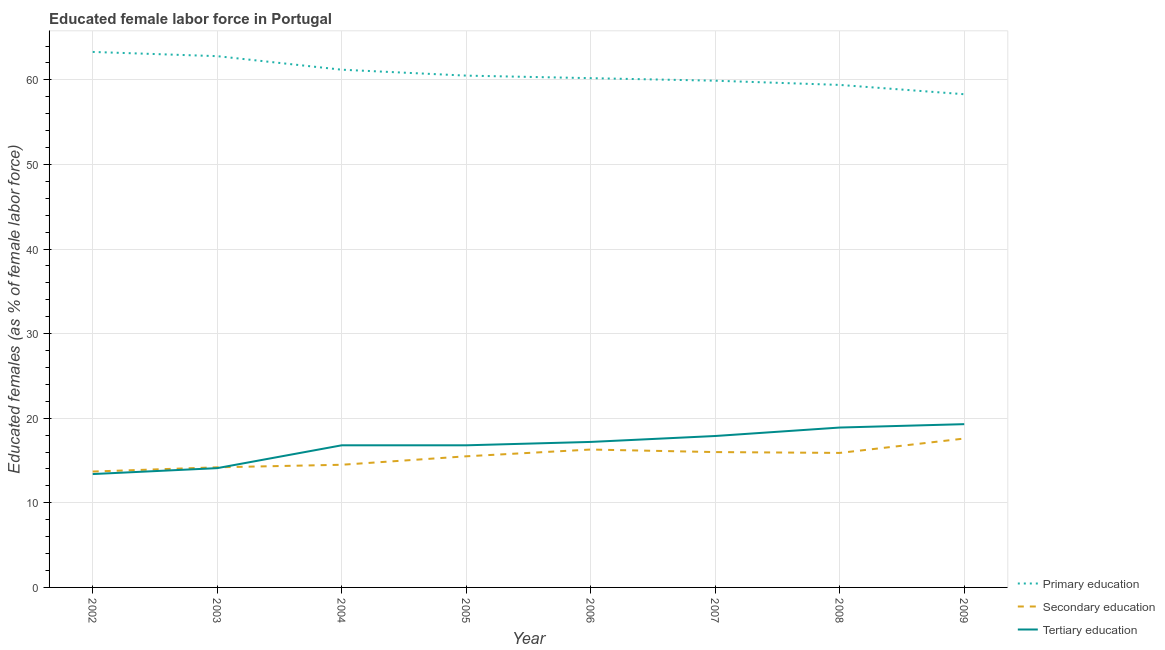How many different coloured lines are there?
Your answer should be very brief. 3. Is the number of lines equal to the number of legend labels?
Keep it short and to the point. Yes. What is the percentage of female labor force who received secondary education in 2006?
Provide a short and direct response. 16.3. Across all years, what is the maximum percentage of female labor force who received tertiary education?
Make the answer very short. 19.3. Across all years, what is the minimum percentage of female labor force who received tertiary education?
Keep it short and to the point. 13.4. In which year was the percentage of female labor force who received tertiary education maximum?
Your answer should be compact. 2009. What is the total percentage of female labor force who received secondary education in the graph?
Your response must be concise. 123.7. What is the difference between the percentage of female labor force who received secondary education in 2004 and that in 2007?
Offer a very short reply. -1.5. What is the difference between the percentage of female labor force who received tertiary education in 2002 and the percentage of female labor force who received secondary education in 2003?
Keep it short and to the point. -0.8. What is the average percentage of female labor force who received primary education per year?
Provide a short and direct response. 60.7. In the year 2004, what is the difference between the percentage of female labor force who received primary education and percentage of female labor force who received secondary education?
Offer a very short reply. 46.7. What is the ratio of the percentage of female labor force who received tertiary education in 2005 to that in 2008?
Give a very brief answer. 0.89. Is the percentage of female labor force who received primary education in 2004 less than that in 2007?
Provide a succinct answer. No. What is the difference between the highest and the second highest percentage of female labor force who received secondary education?
Your response must be concise. 1.3. In how many years, is the percentage of female labor force who received secondary education greater than the average percentage of female labor force who received secondary education taken over all years?
Your answer should be very brief. 5. Is the sum of the percentage of female labor force who received primary education in 2002 and 2009 greater than the maximum percentage of female labor force who received secondary education across all years?
Keep it short and to the point. Yes. Does the percentage of female labor force who received primary education monotonically increase over the years?
Offer a terse response. No. Is the percentage of female labor force who received secondary education strictly greater than the percentage of female labor force who received primary education over the years?
Ensure brevity in your answer.  No. How many years are there in the graph?
Give a very brief answer. 8. What is the difference between two consecutive major ticks on the Y-axis?
Your answer should be compact. 10. Are the values on the major ticks of Y-axis written in scientific E-notation?
Offer a terse response. No. Does the graph contain any zero values?
Offer a terse response. No. Does the graph contain grids?
Ensure brevity in your answer.  Yes. How many legend labels are there?
Provide a short and direct response. 3. How are the legend labels stacked?
Provide a succinct answer. Vertical. What is the title of the graph?
Give a very brief answer. Educated female labor force in Portugal. Does "Maunufacturing" appear as one of the legend labels in the graph?
Give a very brief answer. No. What is the label or title of the Y-axis?
Your response must be concise. Educated females (as % of female labor force). What is the Educated females (as % of female labor force) in Primary education in 2002?
Ensure brevity in your answer.  63.3. What is the Educated females (as % of female labor force) in Secondary education in 2002?
Keep it short and to the point. 13.7. What is the Educated females (as % of female labor force) of Tertiary education in 2002?
Offer a terse response. 13.4. What is the Educated females (as % of female labor force) in Primary education in 2003?
Offer a terse response. 62.8. What is the Educated females (as % of female labor force) in Secondary education in 2003?
Offer a very short reply. 14.2. What is the Educated females (as % of female labor force) in Tertiary education in 2003?
Offer a terse response. 14.1. What is the Educated females (as % of female labor force) of Primary education in 2004?
Make the answer very short. 61.2. What is the Educated females (as % of female labor force) in Tertiary education in 2004?
Give a very brief answer. 16.8. What is the Educated females (as % of female labor force) in Primary education in 2005?
Make the answer very short. 60.5. What is the Educated females (as % of female labor force) in Tertiary education in 2005?
Give a very brief answer. 16.8. What is the Educated females (as % of female labor force) of Primary education in 2006?
Ensure brevity in your answer.  60.2. What is the Educated females (as % of female labor force) of Secondary education in 2006?
Ensure brevity in your answer.  16.3. What is the Educated females (as % of female labor force) of Tertiary education in 2006?
Make the answer very short. 17.2. What is the Educated females (as % of female labor force) of Primary education in 2007?
Give a very brief answer. 59.9. What is the Educated females (as % of female labor force) in Secondary education in 2007?
Your response must be concise. 16. What is the Educated females (as % of female labor force) in Tertiary education in 2007?
Your answer should be compact. 17.9. What is the Educated females (as % of female labor force) of Primary education in 2008?
Offer a terse response. 59.4. What is the Educated females (as % of female labor force) in Secondary education in 2008?
Your answer should be very brief. 15.9. What is the Educated females (as % of female labor force) of Tertiary education in 2008?
Offer a terse response. 18.9. What is the Educated females (as % of female labor force) of Primary education in 2009?
Provide a succinct answer. 58.3. What is the Educated females (as % of female labor force) in Secondary education in 2009?
Your answer should be compact. 17.6. What is the Educated females (as % of female labor force) in Tertiary education in 2009?
Your response must be concise. 19.3. Across all years, what is the maximum Educated females (as % of female labor force) in Primary education?
Ensure brevity in your answer.  63.3. Across all years, what is the maximum Educated females (as % of female labor force) of Secondary education?
Your answer should be very brief. 17.6. Across all years, what is the maximum Educated females (as % of female labor force) in Tertiary education?
Your answer should be very brief. 19.3. Across all years, what is the minimum Educated females (as % of female labor force) in Primary education?
Offer a very short reply. 58.3. Across all years, what is the minimum Educated females (as % of female labor force) in Secondary education?
Offer a very short reply. 13.7. Across all years, what is the minimum Educated females (as % of female labor force) in Tertiary education?
Keep it short and to the point. 13.4. What is the total Educated females (as % of female labor force) in Primary education in the graph?
Your answer should be very brief. 485.6. What is the total Educated females (as % of female labor force) of Secondary education in the graph?
Your response must be concise. 123.7. What is the total Educated females (as % of female labor force) of Tertiary education in the graph?
Give a very brief answer. 134.4. What is the difference between the Educated females (as % of female labor force) in Secondary education in 2002 and that in 2003?
Your answer should be very brief. -0.5. What is the difference between the Educated females (as % of female labor force) in Secondary education in 2002 and that in 2004?
Your response must be concise. -0.8. What is the difference between the Educated females (as % of female labor force) in Primary education in 2002 and that in 2005?
Provide a succinct answer. 2.8. What is the difference between the Educated females (as % of female labor force) in Secondary education in 2002 and that in 2005?
Keep it short and to the point. -1.8. What is the difference between the Educated females (as % of female labor force) in Tertiary education in 2002 and that in 2006?
Your answer should be compact. -3.8. What is the difference between the Educated females (as % of female labor force) of Secondary education in 2002 and that in 2007?
Your answer should be very brief. -2.3. What is the difference between the Educated females (as % of female labor force) in Tertiary education in 2002 and that in 2008?
Your answer should be very brief. -5.5. What is the difference between the Educated females (as % of female labor force) of Secondary education in 2002 and that in 2009?
Ensure brevity in your answer.  -3.9. What is the difference between the Educated females (as % of female labor force) of Secondary education in 2003 and that in 2004?
Provide a short and direct response. -0.3. What is the difference between the Educated females (as % of female labor force) in Tertiary education in 2003 and that in 2004?
Ensure brevity in your answer.  -2.7. What is the difference between the Educated females (as % of female labor force) in Secondary education in 2003 and that in 2005?
Offer a terse response. -1.3. What is the difference between the Educated females (as % of female labor force) of Primary education in 2003 and that in 2006?
Ensure brevity in your answer.  2.6. What is the difference between the Educated females (as % of female labor force) in Secondary education in 2003 and that in 2006?
Keep it short and to the point. -2.1. What is the difference between the Educated females (as % of female labor force) in Primary education in 2003 and that in 2007?
Ensure brevity in your answer.  2.9. What is the difference between the Educated females (as % of female labor force) in Secondary education in 2003 and that in 2007?
Make the answer very short. -1.8. What is the difference between the Educated females (as % of female labor force) of Primary education in 2003 and that in 2008?
Keep it short and to the point. 3.4. What is the difference between the Educated females (as % of female labor force) in Secondary education in 2003 and that in 2008?
Your response must be concise. -1.7. What is the difference between the Educated females (as % of female labor force) in Tertiary education in 2003 and that in 2009?
Give a very brief answer. -5.2. What is the difference between the Educated females (as % of female labor force) in Primary education in 2004 and that in 2005?
Offer a terse response. 0.7. What is the difference between the Educated females (as % of female labor force) in Secondary education in 2004 and that in 2005?
Ensure brevity in your answer.  -1. What is the difference between the Educated females (as % of female labor force) in Tertiary education in 2004 and that in 2005?
Provide a short and direct response. 0. What is the difference between the Educated females (as % of female labor force) in Primary education in 2004 and that in 2006?
Your response must be concise. 1. What is the difference between the Educated females (as % of female labor force) in Primary education in 2004 and that in 2007?
Give a very brief answer. 1.3. What is the difference between the Educated females (as % of female labor force) of Secondary education in 2004 and that in 2007?
Ensure brevity in your answer.  -1.5. What is the difference between the Educated females (as % of female labor force) of Tertiary education in 2004 and that in 2007?
Make the answer very short. -1.1. What is the difference between the Educated females (as % of female labor force) of Primary education in 2004 and that in 2009?
Give a very brief answer. 2.9. What is the difference between the Educated females (as % of female labor force) in Tertiary education in 2004 and that in 2009?
Your response must be concise. -2.5. What is the difference between the Educated females (as % of female labor force) of Primary education in 2005 and that in 2006?
Your answer should be compact. 0.3. What is the difference between the Educated females (as % of female labor force) in Tertiary education in 2005 and that in 2006?
Provide a succinct answer. -0.4. What is the difference between the Educated females (as % of female labor force) in Primary education in 2005 and that in 2007?
Offer a very short reply. 0.6. What is the difference between the Educated females (as % of female labor force) in Secondary education in 2005 and that in 2007?
Offer a terse response. -0.5. What is the difference between the Educated females (as % of female labor force) of Primary education in 2005 and that in 2008?
Make the answer very short. 1.1. What is the difference between the Educated females (as % of female labor force) of Primary education in 2005 and that in 2009?
Keep it short and to the point. 2.2. What is the difference between the Educated females (as % of female labor force) in Secondary education in 2005 and that in 2009?
Your response must be concise. -2.1. What is the difference between the Educated females (as % of female labor force) in Primary education in 2006 and that in 2007?
Ensure brevity in your answer.  0.3. What is the difference between the Educated females (as % of female labor force) of Secondary education in 2006 and that in 2007?
Your response must be concise. 0.3. What is the difference between the Educated females (as % of female labor force) of Tertiary education in 2006 and that in 2007?
Ensure brevity in your answer.  -0.7. What is the difference between the Educated females (as % of female labor force) of Secondary education in 2006 and that in 2008?
Keep it short and to the point. 0.4. What is the difference between the Educated females (as % of female labor force) in Tertiary education in 2006 and that in 2008?
Make the answer very short. -1.7. What is the difference between the Educated females (as % of female labor force) in Secondary education in 2006 and that in 2009?
Your answer should be very brief. -1.3. What is the difference between the Educated females (as % of female labor force) of Tertiary education in 2006 and that in 2009?
Your answer should be very brief. -2.1. What is the difference between the Educated females (as % of female labor force) of Primary education in 2007 and that in 2009?
Your response must be concise. 1.6. What is the difference between the Educated females (as % of female labor force) of Secondary education in 2007 and that in 2009?
Keep it short and to the point. -1.6. What is the difference between the Educated females (as % of female labor force) of Primary education in 2008 and that in 2009?
Your response must be concise. 1.1. What is the difference between the Educated females (as % of female labor force) in Primary education in 2002 and the Educated females (as % of female labor force) in Secondary education in 2003?
Provide a short and direct response. 49.1. What is the difference between the Educated females (as % of female labor force) of Primary education in 2002 and the Educated females (as % of female labor force) of Tertiary education in 2003?
Ensure brevity in your answer.  49.2. What is the difference between the Educated females (as % of female labor force) of Secondary education in 2002 and the Educated females (as % of female labor force) of Tertiary education in 2003?
Provide a short and direct response. -0.4. What is the difference between the Educated females (as % of female labor force) in Primary education in 2002 and the Educated females (as % of female labor force) in Secondary education in 2004?
Your response must be concise. 48.8. What is the difference between the Educated females (as % of female labor force) of Primary education in 2002 and the Educated females (as % of female labor force) of Tertiary education in 2004?
Give a very brief answer. 46.5. What is the difference between the Educated females (as % of female labor force) in Secondary education in 2002 and the Educated females (as % of female labor force) in Tertiary education in 2004?
Give a very brief answer. -3.1. What is the difference between the Educated females (as % of female labor force) in Primary education in 2002 and the Educated females (as % of female labor force) in Secondary education in 2005?
Keep it short and to the point. 47.8. What is the difference between the Educated females (as % of female labor force) in Primary education in 2002 and the Educated females (as % of female labor force) in Tertiary education in 2005?
Your answer should be compact. 46.5. What is the difference between the Educated females (as % of female labor force) in Primary education in 2002 and the Educated females (as % of female labor force) in Tertiary education in 2006?
Offer a very short reply. 46.1. What is the difference between the Educated females (as % of female labor force) in Secondary education in 2002 and the Educated females (as % of female labor force) in Tertiary education in 2006?
Your answer should be compact. -3.5. What is the difference between the Educated females (as % of female labor force) of Primary education in 2002 and the Educated females (as % of female labor force) of Secondary education in 2007?
Make the answer very short. 47.3. What is the difference between the Educated females (as % of female labor force) of Primary education in 2002 and the Educated females (as % of female labor force) of Tertiary education in 2007?
Your response must be concise. 45.4. What is the difference between the Educated females (as % of female labor force) in Primary education in 2002 and the Educated females (as % of female labor force) in Secondary education in 2008?
Keep it short and to the point. 47.4. What is the difference between the Educated females (as % of female labor force) in Primary education in 2002 and the Educated females (as % of female labor force) in Tertiary education in 2008?
Your answer should be very brief. 44.4. What is the difference between the Educated females (as % of female labor force) of Secondary education in 2002 and the Educated females (as % of female labor force) of Tertiary education in 2008?
Provide a succinct answer. -5.2. What is the difference between the Educated females (as % of female labor force) of Primary education in 2002 and the Educated females (as % of female labor force) of Secondary education in 2009?
Provide a short and direct response. 45.7. What is the difference between the Educated females (as % of female labor force) of Primary education in 2002 and the Educated females (as % of female labor force) of Tertiary education in 2009?
Your answer should be very brief. 44. What is the difference between the Educated females (as % of female labor force) of Primary education in 2003 and the Educated females (as % of female labor force) of Secondary education in 2004?
Make the answer very short. 48.3. What is the difference between the Educated females (as % of female labor force) in Primary education in 2003 and the Educated females (as % of female labor force) in Tertiary education in 2004?
Your response must be concise. 46. What is the difference between the Educated females (as % of female labor force) of Secondary education in 2003 and the Educated females (as % of female labor force) of Tertiary education in 2004?
Make the answer very short. -2.6. What is the difference between the Educated females (as % of female labor force) of Primary education in 2003 and the Educated females (as % of female labor force) of Secondary education in 2005?
Offer a very short reply. 47.3. What is the difference between the Educated females (as % of female labor force) of Primary education in 2003 and the Educated females (as % of female labor force) of Tertiary education in 2005?
Give a very brief answer. 46. What is the difference between the Educated females (as % of female labor force) in Primary education in 2003 and the Educated females (as % of female labor force) in Secondary education in 2006?
Your answer should be very brief. 46.5. What is the difference between the Educated females (as % of female labor force) of Primary education in 2003 and the Educated females (as % of female labor force) of Tertiary education in 2006?
Your response must be concise. 45.6. What is the difference between the Educated females (as % of female labor force) of Primary education in 2003 and the Educated females (as % of female labor force) of Secondary education in 2007?
Give a very brief answer. 46.8. What is the difference between the Educated females (as % of female labor force) in Primary education in 2003 and the Educated females (as % of female labor force) in Tertiary education in 2007?
Your answer should be compact. 44.9. What is the difference between the Educated females (as % of female labor force) of Secondary education in 2003 and the Educated females (as % of female labor force) of Tertiary education in 2007?
Ensure brevity in your answer.  -3.7. What is the difference between the Educated females (as % of female labor force) in Primary education in 2003 and the Educated females (as % of female labor force) in Secondary education in 2008?
Give a very brief answer. 46.9. What is the difference between the Educated females (as % of female labor force) in Primary education in 2003 and the Educated females (as % of female labor force) in Tertiary education in 2008?
Provide a succinct answer. 43.9. What is the difference between the Educated females (as % of female labor force) of Primary education in 2003 and the Educated females (as % of female labor force) of Secondary education in 2009?
Your answer should be very brief. 45.2. What is the difference between the Educated females (as % of female labor force) in Primary education in 2003 and the Educated females (as % of female labor force) in Tertiary education in 2009?
Ensure brevity in your answer.  43.5. What is the difference between the Educated females (as % of female labor force) of Secondary education in 2003 and the Educated females (as % of female labor force) of Tertiary education in 2009?
Give a very brief answer. -5.1. What is the difference between the Educated females (as % of female labor force) in Primary education in 2004 and the Educated females (as % of female labor force) in Secondary education in 2005?
Offer a very short reply. 45.7. What is the difference between the Educated females (as % of female labor force) in Primary education in 2004 and the Educated females (as % of female labor force) in Tertiary education in 2005?
Ensure brevity in your answer.  44.4. What is the difference between the Educated females (as % of female labor force) of Secondary education in 2004 and the Educated females (as % of female labor force) of Tertiary education in 2005?
Your answer should be compact. -2.3. What is the difference between the Educated females (as % of female labor force) in Primary education in 2004 and the Educated females (as % of female labor force) in Secondary education in 2006?
Your response must be concise. 44.9. What is the difference between the Educated females (as % of female labor force) of Primary education in 2004 and the Educated females (as % of female labor force) of Secondary education in 2007?
Provide a short and direct response. 45.2. What is the difference between the Educated females (as % of female labor force) of Primary education in 2004 and the Educated females (as % of female labor force) of Tertiary education in 2007?
Offer a terse response. 43.3. What is the difference between the Educated females (as % of female labor force) in Primary education in 2004 and the Educated females (as % of female labor force) in Secondary education in 2008?
Your answer should be compact. 45.3. What is the difference between the Educated females (as % of female labor force) of Primary education in 2004 and the Educated females (as % of female labor force) of Tertiary education in 2008?
Your answer should be compact. 42.3. What is the difference between the Educated females (as % of female labor force) of Secondary education in 2004 and the Educated females (as % of female labor force) of Tertiary education in 2008?
Give a very brief answer. -4.4. What is the difference between the Educated females (as % of female labor force) in Primary education in 2004 and the Educated females (as % of female labor force) in Secondary education in 2009?
Give a very brief answer. 43.6. What is the difference between the Educated females (as % of female labor force) in Primary education in 2004 and the Educated females (as % of female labor force) in Tertiary education in 2009?
Make the answer very short. 41.9. What is the difference between the Educated females (as % of female labor force) of Primary education in 2005 and the Educated females (as % of female labor force) of Secondary education in 2006?
Make the answer very short. 44.2. What is the difference between the Educated females (as % of female labor force) of Primary education in 2005 and the Educated females (as % of female labor force) of Tertiary education in 2006?
Your response must be concise. 43.3. What is the difference between the Educated females (as % of female labor force) in Secondary education in 2005 and the Educated females (as % of female labor force) in Tertiary education in 2006?
Make the answer very short. -1.7. What is the difference between the Educated females (as % of female labor force) of Primary education in 2005 and the Educated females (as % of female labor force) of Secondary education in 2007?
Your response must be concise. 44.5. What is the difference between the Educated females (as % of female labor force) in Primary education in 2005 and the Educated females (as % of female labor force) in Tertiary education in 2007?
Make the answer very short. 42.6. What is the difference between the Educated females (as % of female labor force) in Primary education in 2005 and the Educated females (as % of female labor force) in Secondary education in 2008?
Keep it short and to the point. 44.6. What is the difference between the Educated females (as % of female labor force) of Primary education in 2005 and the Educated females (as % of female labor force) of Tertiary education in 2008?
Provide a short and direct response. 41.6. What is the difference between the Educated females (as % of female labor force) in Secondary education in 2005 and the Educated females (as % of female labor force) in Tertiary education in 2008?
Your answer should be compact. -3.4. What is the difference between the Educated females (as % of female labor force) of Primary education in 2005 and the Educated females (as % of female labor force) of Secondary education in 2009?
Keep it short and to the point. 42.9. What is the difference between the Educated females (as % of female labor force) in Primary education in 2005 and the Educated females (as % of female labor force) in Tertiary education in 2009?
Offer a very short reply. 41.2. What is the difference between the Educated females (as % of female labor force) in Secondary education in 2005 and the Educated females (as % of female labor force) in Tertiary education in 2009?
Your answer should be compact. -3.8. What is the difference between the Educated females (as % of female labor force) in Primary education in 2006 and the Educated females (as % of female labor force) in Secondary education in 2007?
Ensure brevity in your answer.  44.2. What is the difference between the Educated females (as % of female labor force) of Primary education in 2006 and the Educated females (as % of female labor force) of Tertiary education in 2007?
Your answer should be very brief. 42.3. What is the difference between the Educated females (as % of female labor force) in Primary education in 2006 and the Educated females (as % of female labor force) in Secondary education in 2008?
Your response must be concise. 44.3. What is the difference between the Educated females (as % of female labor force) of Primary education in 2006 and the Educated females (as % of female labor force) of Tertiary education in 2008?
Ensure brevity in your answer.  41.3. What is the difference between the Educated females (as % of female labor force) of Secondary education in 2006 and the Educated females (as % of female labor force) of Tertiary education in 2008?
Ensure brevity in your answer.  -2.6. What is the difference between the Educated females (as % of female labor force) in Primary education in 2006 and the Educated females (as % of female labor force) in Secondary education in 2009?
Provide a short and direct response. 42.6. What is the difference between the Educated females (as % of female labor force) of Primary education in 2006 and the Educated females (as % of female labor force) of Tertiary education in 2009?
Provide a succinct answer. 40.9. What is the difference between the Educated females (as % of female labor force) in Secondary education in 2006 and the Educated females (as % of female labor force) in Tertiary education in 2009?
Offer a terse response. -3. What is the difference between the Educated females (as % of female labor force) of Primary education in 2007 and the Educated females (as % of female labor force) of Secondary education in 2008?
Give a very brief answer. 44. What is the difference between the Educated females (as % of female labor force) in Primary education in 2007 and the Educated females (as % of female labor force) in Secondary education in 2009?
Your answer should be compact. 42.3. What is the difference between the Educated females (as % of female labor force) of Primary education in 2007 and the Educated females (as % of female labor force) of Tertiary education in 2009?
Ensure brevity in your answer.  40.6. What is the difference between the Educated females (as % of female labor force) of Primary education in 2008 and the Educated females (as % of female labor force) of Secondary education in 2009?
Ensure brevity in your answer.  41.8. What is the difference between the Educated females (as % of female labor force) of Primary education in 2008 and the Educated females (as % of female labor force) of Tertiary education in 2009?
Make the answer very short. 40.1. What is the difference between the Educated females (as % of female labor force) of Secondary education in 2008 and the Educated females (as % of female labor force) of Tertiary education in 2009?
Give a very brief answer. -3.4. What is the average Educated females (as % of female labor force) of Primary education per year?
Provide a short and direct response. 60.7. What is the average Educated females (as % of female labor force) in Secondary education per year?
Your answer should be compact. 15.46. In the year 2002, what is the difference between the Educated females (as % of female labor force) in Primary education and Educated females (as % of female labor force) in Secondary education?
Give a very brief answer. 49.6. In the year 2002, what is the difference between the Educated females (as % of female labor force) in Primary education and Educated females (as % of female labor force) in Tertiary education?
Keep it short and to the point. 49.9. In the year 2002, what is the difference between the Educated females (as % of female labor force) in Secondary education and Educated females (as % of female labor force) in Tertiary education?
Ensure brevity in your answer.  0.3. In the year 2003, what is the difference between the Educated females (as % of female labor force) of Primary education and Educated females (as % of female labor force) of Secondary education?
Offer a terse response. 48.6. In the year 2003, what is the difference between the Educated females (as % of female labor force) of Primary education and Educated females (as % of female labor force) of Tertiary education?
Your answer should be compact. 48.7. In the year 2004, what is the difference between the Educated females (as % of female labor force) in Primary education and Educated females (as % of female labor force) in Secondary education?
Ensure brevity in your answer.  46.7. In the year 2004, what is the difference between the Educated females (as % of female labor force) of Primary education and Educated females (as % of female labor force) of Tertiary education?
Provide a succinct answer. 44.4. In the year 2005, what is the difference between the Educated females (as % of female labor force) in Primary education and Educated females (as % of female labor force) in Secondary education?
Provide a succinct answer. 45. In the year 2005, what is the difference between the Educated females (as % of female labor force) of Primary education and Educated females (as % of female labor force) of Tertiary education?
Offer a very short reply. 43.7. In the year 2006, what is the difference between the Educated females (as % of female labor force) of Primary education and Educated females (as % of female labor force) of Secondary education?
Your answer should be compact. 43.9. In the year 2007, what is the difference between the Educated females (as % of female labor force) in Primary education and Educated females (as % of female labor force) in Secondary education?
Your answer should be compact. 43.9. In the year 2007, what is the difference between the Educated females (as % of female labor force) in Primary education and Educated females (as % of female labor force) in Tertiary education?
Make the answer very short. 42. In the year 2007, what is the difference between the Educated females (as % of female labor force) of Secondary education and Educated females (as % of female labor force) of Tertiary education?
Provide a short and direct response. -1.9. In the year 2008, what is the difference between the Educated females (as % of female labor force) in Primary education and Educated females (as % of female labor force) in Secondary education?
Offer a very short reply. 43.5. In the year 2008, what is the difference between the Educated females (as % of female labor force) in Primary education and Educated females (as % of female labor force) in Tertiary education?
Provide a short and direct response. 40.5. In the year 2009, what is the difference between the Educated females (as % of female labor force) in Primary education and Educated females (as % of female labor force) in Secondary education?
Your response must be concise. 40.7. In the year 2009, what is the difference between the Educated females (as % of female labor force) in Primary education and Educated females (as % of female labor force) in Tertiary education?
Give a very brief answer. 39. In the year 2009, what is the difference between the Educated females (as % of female labor force) in Secondary education and Educated females (as % of female labor force) in Tertiary education?
Provide a succinct answer. -1.7. What is the ratio of the Educated females (as % of female labor force) in Primary education in 2002 to that in 2003?
Your response must be concise. 1.01. What is the ratio of the Educated females (as % of female labor force) in Secondary education in 2002 to that in 2003?
Give a very brief answer. 0.96. What is the ratio of the Educated females (as % of female labor force) of Tertiary education in 2002 to that in 2003?
Your response must be concise. 0.95. What is the ratio of the Educated females (as % of female labor force) of Primary education in 2002 to that in 2004?
Provide a short and direct response. 1.03. What is the ratio of the Educated females (as % of female labor force) of Secondary education in 2002 to that in 2004?
Provide a succinct answer. 0.94. What is the ratio of the Educated females (as % of female labor force) in Tertiary education in 2002 to that in 2004?
Provide a short and direct response. 0.8. What is the ratio of the Educated females (as % of female labor force) in Primary education in 2002 to that in 2005?
Provide a succinct answer. 1.05. What is the ratio of the Educated females (as % of female labor force) in Secondary education in 2002 to that in 2005?
Offer a very short reply. 0.88. What is the ratio of the Educated females (as % of female labor force) of Tertiary education in 2002 to that in 2005?
Make the answer very short. 0.8. What is the ratio of the Educated females (as % of female labor force) of Primary education in 2002 to that in 2006?
Provide a succinct answer. 1.05. What is the ratio of the Educated females (as % of female labor force) of Secondary education in 2002 to that in 2006?
Ensure brevity in your answer.  0.84. What is the ratio of the Educated females (as % of female labor force) in Tertiary education in 2002 to that in 2006?
Your answer should be very brief. 0.78. What is the ratio of the Educated females (as % of female labor force) of Primary education in 2002 to that in 2007?
Ensure brevity in your answer.  1.06. What is the ratio of the Educated females (as % of female labor force) of Secondary education in 2002 to that in 2007?
Your answer should be compact. 0.86. What is the ratio of the Educated females (as % of female labor force) of Tertiary education in 2002 to that in 2007?
Provide a short and direct response. 0.75. What is the ratio of the Educated females (as % of female labor force) in Primary education in 2002 to that in 2008?
Offer a very short reply. 1.07. What is the ratio of the Educated females (as % of female labor force) of Secondary education in 2002 to that in 2008?
Offer a very short reply. 0.86. What is the ratio of the Educated females (as % of female labor force) in Tertiary education in 2002 to that in 2008?
Make the answer very short. 0.71. What is the ratio of the Educated females (as % of female labor force) in Primary education in 2002 to that in 2009?
Make the answer very short. 1.09. What is the ratio of the Educated females (as % of female labor force) of Secondary education in 2002 to that in 2009?
Offer a terse response. 0.78. What is the ratio of the Educated females (as % of female labor force) in Tertiary education in 2002 to that in 2009?
Give a very brief answer. 0.69. What is the ratio of the Educated females (as % of female labor force) of Primary education in 2003 to that in 2004?
Offer a very short reply. 1.03. What is the ratio of the Educated females (as % of female labor force) in Secondary education in 2003 to that in 2004?
Give a very brief answer. 0.98. What is the ratio of the Educated females (as % of female labor force) of Tertiary education in 2003 to that in 2004?
Give a very brief answer. 0.84. What is the ratio of the Educated females (as % of female labor force) of Primary education in 2003 to that in 2005?
Offer a very short reply. 1.04. What is the ratio of the Educated females (as % of female labor force) in Secondary education in 2003 to that in 2005?
Offer a very short reply. 0.92. What is the ratio of the Educated females (as % of female labor force) of Tertiary education in 2003 to that in 2005?
Your answer should be very brief. 0.84. What is the ratio of the Educated females (as % of female labor force) of Primary education in 2003 to that in 2006?
Your response must be concise. 1.04. What is the ratio of the Educated females (as % of female labor force) in Secondary education in 2003 to that in 2006?
Give a very brief answer. 0.87. What is the ratio of the Educated females (as % of female labor force) of Tertiary education in 2003 to that in 2006?
Provide a short and direct response. 0.82. What is the ratio of the Educated females (as % of female labor force) in Primary education in 2003 to that in 2007?
Provide a short and direct response. 1.05. What is the ratio of the Educated females (as % of female labor force) in Secondary education in 2003 to that in 2007?
Give a very brief answer. 0.89. What is the ratio of the Educated females (as % of female labor force) in Tertiary education in 2003 to that in 2007?
Give a very brief answer. 0.79. What is the ratio of the Educated females (as % of female labor force) in Primary education in 2003 to that in 2008?
Your response must be concise. 1.06. What is the ratio of the Educated females (as % of female labor force) in Secondary education in 2003 to that in 2008?
Provide a short and direct response. 0.89. What is the ratio of the Educated females (as % of female labor force) in Tertiary education in 2003 to that in 2008?
Your answer should be compact. 0.75. What is the ratio of the Educated females (as % of female labor force) in Primary education in 2003 to that in 2009?
Offer a terse response. 1.08. What is the ratio of the Educated females (as % of female labor force) in Secondary education in 2003 to that in 2009?
Offer a very short reply. 0.81. What is the ratio of the Educated females (as % of female labor force) of Tertiary education in 2003 to that in 2009?
Keep it short and to the point. 0.73. What is the ratio of the Educated females (as % of female labor force) in Primary education in 2004 to that in 2005?
Provide a succinct answer. 1.01. What is the ratio of the Educated females (as % of female labor force) of Secondary education in 2004 to that in 2005?
Keep it short and to the point. 0.94. What is the ratio of the Educated females (as % of female labor force) of Tertiary education in 2004 to that in 2005?
Give a very brief answer. 1. What is the ratio of the Educated females (as % of female labor force) of Primary education in 2004 to that in 2006?
Your response must be concise. 1.02. What is the ratio of the Educated females (as % of female labor force) in Secondary education in 2004 to that in 2006?
Offer a very short reply. 0.89. What is the ratio of the Educated females (as % of female labor force) of Tertiary education in 2004 to that in 2006?
Offer a very short reply. 0.98. What is the ratio of the Educated females (as % of female labor force) of Primary education in 2004 to that in 2007?
Keep it short and to the point. 1.02. What is the ratio of the Educated females (as % of female labor force) in Secondary education in 2004 to that in 2007?
Make the answer very short. 0.91. What is the ratio of the Educated females (as % of female labor force) in Tertiary education in 2004 to that in 2007?
Your answer should be very brief. 0.94. What is the ratio of the Educated females (as % of female labor force) in Primary education in 2004 to that in 2008?
Give a very brief answer. 1.03. What is the ratio of the Educated females (as % of female labor force) in Secondary education in 2004 to that in 2008?
Offer a terse response. 0.91. What is the ratio of the Educated females (as % of female labor force) in Primary education in 2004 to that in 2009?
Your answer should be compact. 1.05. What is the ratio of the Educated females (as % of female labor force) of Secondary education in 2004 to that in 2009?
Your answer should be compact. 0.82. What is the ratio of the Educated females (as % of female labor force) in Tertiary education in 2004 to that in 2009?
Offer a very short reply. 0.87. What is the ratio of the Educated females (as % of female labor force) in Secondary education in 2005 to that in 2006?
Give a very brief answer. 0.95. What is the ratio of the Educated females (as % of female labor force) in Tertiary education in 2005 to that in 2006?
Make the answer very short. 0.98. What is the ratio of the Educated females (as % of female labor force) in Primary education in 2005 to that in 2007?
Your answer should be compact. 1.01. What is the ratio of the Educated females (as % of female labor force) of Secondary education in 2005 to that in 2007?
Provide a succinct answer. 0.97. What is the ratio of the Educated females (as % of female labor force) of Tertiary education in 2005 to that in 2007?
Offer a very short reply. 0.94. What is the ratio of the Educated females (as % of female labor force) of Primary education in 2005 to that in 2008?
Keep it short and to the point. 1.02. What is the ratio of the Educated females (as % of female labor force) in Secondary education in 2005 to that in 2008?
Provide a short and direct response. 0.97. What is the ratio of the Educated females (as % of female labor force) of Primary education in 2005 to that in 2009?
Your response must be concise. 1.04. What is the ratio of the Educated females (as % of female labor force) of Secondary education in 2005 to that in 2009?
Offer a very short reply. 0.88. What is the ratio of the Educated females (as % of female labor force) in Tertiary education in 2005 to that in 2009?
Ensure brevity in your answer.  0.87. What is the ratio of the Educated females (as % of female labor force) of Secondary education in 2006 to that in 2007?
Ensure brevity in your answer.  1.02. What is the ratio of the Educated females (as % of female labor force) of Tertiary education in 2006 to that in 2007?
Give a very brief answer. 0.96. What is the ratio of the Educated females (as % of female labor force) in Primary education in 2006 to that in 2008?
Ensure brevity in your answer.  1.01. What is the ratio of the Educated females (as % of female labor force) of Secondary education in 2006 to that in 2008?
Offer a terse response. 1.03. What is the ratio of the Educated females (as % of female labor force) of Tertiary education in 2006 to that in 2008?
Make the answer very short. 0.91. What is the ratio of the Educated females (as % of female labor force) of Primary education in 2006 to that in 2009?
Your answer should be compact. 1.03. What is the ratio of the Educated females (as % of female labor force) of Secondary education in 2006 to that in 2009?
Offer a terse response. 0.93. What is the ratio of the Educated females (as % of female labor force) in Tertiary education in 2006 to that in 2009?
Your answer should be compact. 0.89. What is the ratio of the Educated females (as % of female labor force) of Primary education in 2007 to that in 2008?
Give a very brief answer. 1.01. What is the ratio of the Educated females (as % of female labor force) in Tertiary education in 2007 to that in 2008?
Keep it short and to the point. 0.95. What is the ratio of the Educated females (as % of female labor force) in Primary education in 2007 to that in 2009?
Ensure brevity in your answer.  1.03. What is the ratio of the Educated females (as % of female labor force) of Secondary education in 2007 to that in 2009?
Provide a short and direct response. 0.91. What is the ratio of the Educated females (as % of female labor force) of Tertiary education in 2007 to that in 2009?
Keep it short and to the point. 0.93. What is the ratio of the Educated females (as % of female labor force) of Primary education in 2008 to that in 2009?
Your answer should be very brief. 1.02. What is the ratio of the Educated females (as % of female labor force) in Secondary education in 2008 to that in 2009?
Your response must be concise. 0.9. What is the ratio of the Educated females (as % of female labor force) of Tertiary education in 2008 to that in 2009?
Provide a succinct answer. 0.98. What is the difference between the highest and the second highest Educated females (as % of female labor force) of Tertiary education?
Give a very brief answer. 0.4. What is the difference between the highest and the lowest Educated females (as % of female labor force) of Secondary education?
Provide a succinct answer. 3.9. 